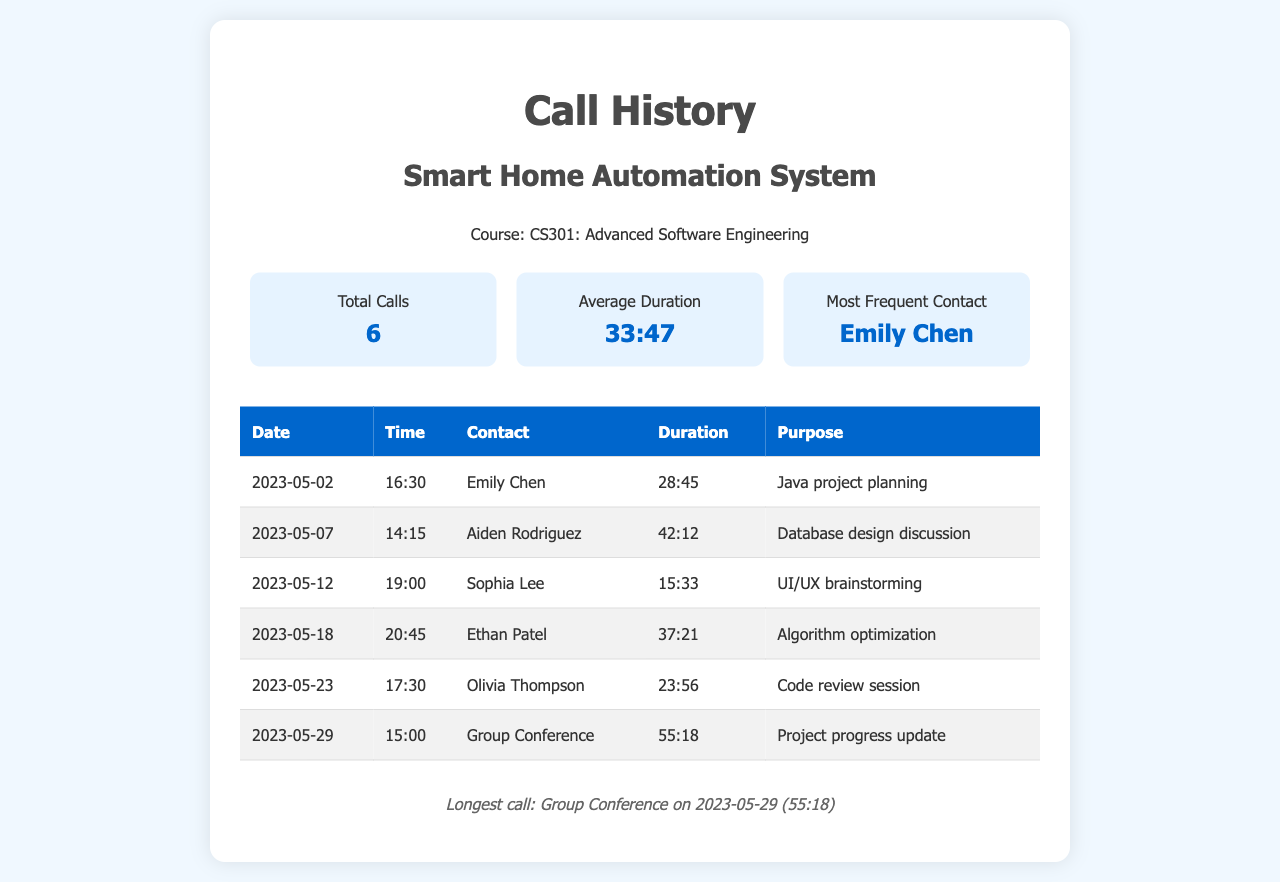What is the total number of calls? The total number of calls is specified in the statistics section of the document, showing that there were 6 calls made in total.
Answer: 6 Who was the most frequent contact? The most frequent contact is highlighted in the statistics section, indicating that Emily Chen was contacted the most.
Answer: Emily Chen What was the longest call duration? The longest call duration is mentioned in the footer, which states the duration of the Group Conference call as 55 minutes and 18 seconds.
Answer: 55:18 When did the call with Aiden Rodriguez take place? The date of the call with Aiden Rodriguez is provided in the table, specifically showing it occurred on May 7, 2023.
Answer: 2023-05-07 What was the purpose of the call on May 12, 2023? The purpose of the call with Sophia Lee on May 12 is listed in the table, describing it as a UI/UX brainstorming session.
Answer: UI/UX brainstorming How many calls were related to project discussions? A review of the table indicates that all listed calls were related to project discussions, so the total matches the total number of calls at 6.
Answer: 6 What time was the Group Conference call? The time of the Group Conference call is specified in the table, which shows it occurred at 15:00.
Answer: 15:00 What was the average duration of the calls? The average duration is calculated and presented in the statistics section, which is indicated to be 33 minutes and 47 seconds.
Answer: 33:47 